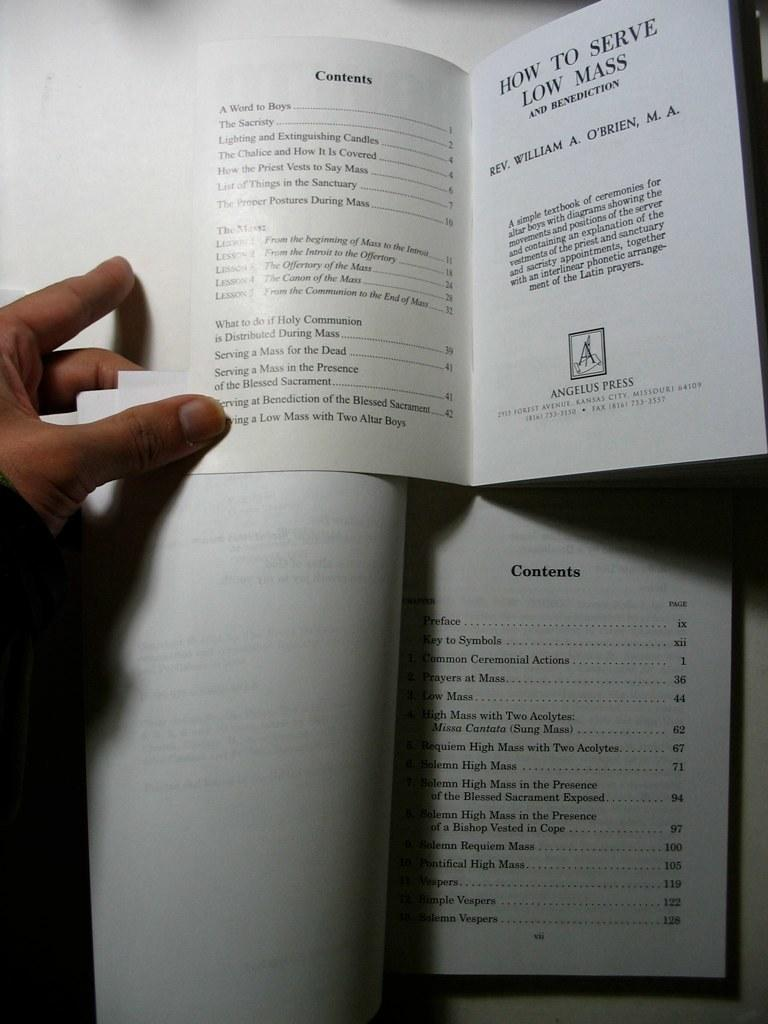<image>
Share a concise interpretation of the image provided. A hand holds open two books' index pages concering how to serve low mass. 